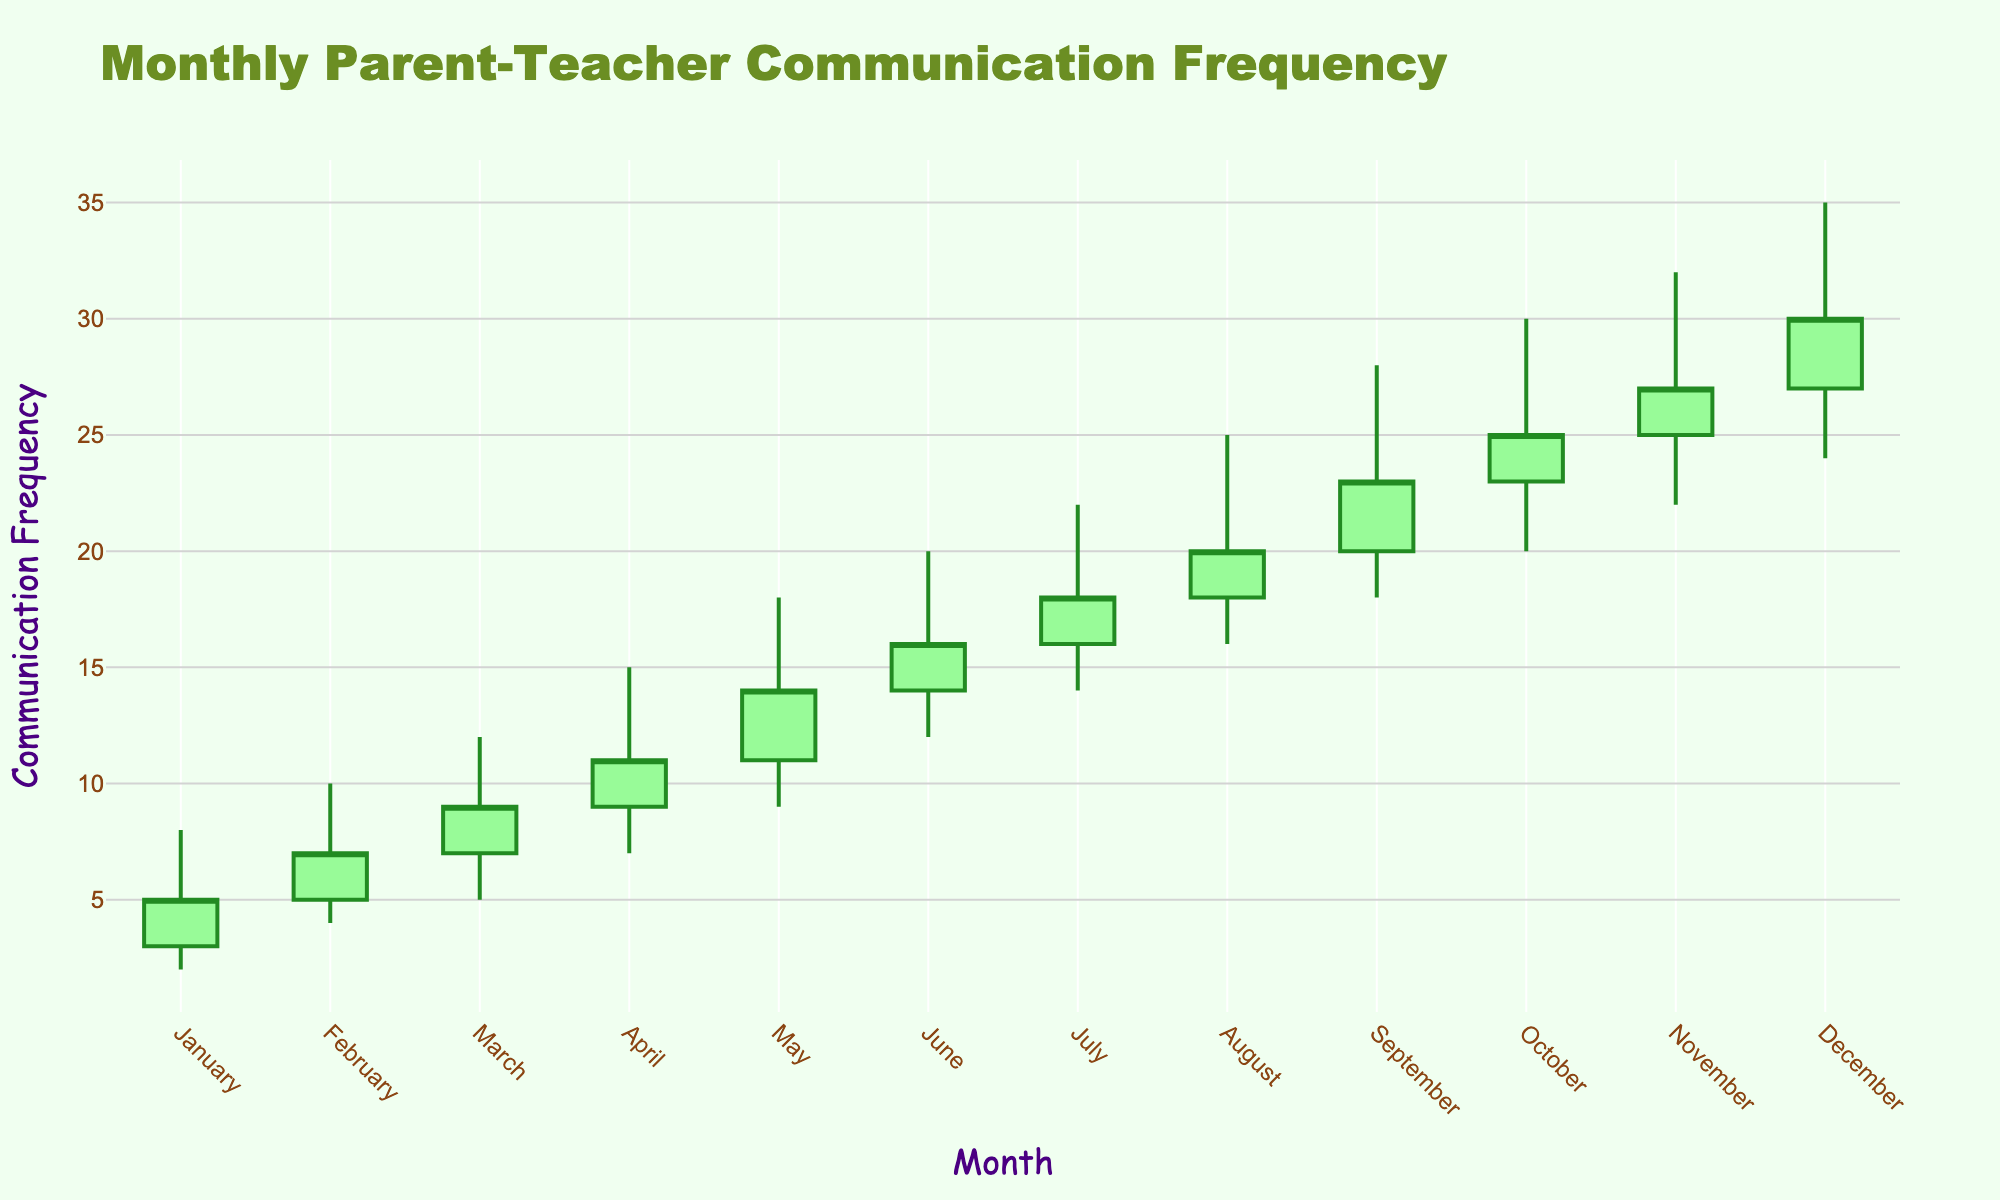What is the title of the figure? The title can be found at the top of the figure. It explicitly states the main topic or subject of the figure.
Answer: Monthly Parent-Teacher Communication Frequency What are the colors used to indicate increasing and decreasing trends? The colors are used to easily differentiate between increasing and decreasing trends at a glance. Increasing trends are in green, and decreasing trends are in red.
Answer: Green and Red How many months show an increase in the closing frequency compared to the opening frequency? We need to count the number of months where the closing value is greater than the opening value. By examining each candlestick, the closing values for January to December are greater than their opening values.
Answer: 12 What is the highest peak (High) observed in the dataset? The highest peak can be found by looking at the highest value on the Y-axis indicated by any high point on the candlesticks. The highest value on the High column is 35.
Answer: 35 Which month had the greatest fluctuation in communication frequency? Fluctuation is indicated by the difference between the High and Low values. The month with the greatest difference needs to be identified. August shows the greatest fluctuation because the difference between 25 and 16 is 9.
Answer: August Which month has the lowest 'Low' value? We need to look at the lowest points of the candlestick (Low values) for each month. The lowest Low value observed is in January, which is 2.
Answer: January Compare the opening frequency of March and November. Which is higher? To compare, look at the opening values for March (7) and November (25). November's value is higher.
Answer: November Was the communication frequency increase between July and August greater than the increase between June and July? To solve this, find the differences for those months: July (16 - 14 = 2), August (20 - 18 = 2). Both differences are equal, so no month had a greater increase.
Answer: No Identify the month where the closing frequency reached 30. Observe the candlesticks to see when 'Close' equals 30. The closing frequency reaches 30 in December.
Answer: December What is the difference between the highest point in May and the lowest point in September? Calculate the difference between the High value for May (18) and the Low value for September (18). Thus, the difference is 28 - 9 = 19.
Answer: 19 